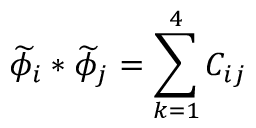<formula> <loc_0><loc_0><loc_500><loc_500>\widetilde { \phi } _ { i } \ast \widetilde { \phi } _ { j } = \sum _ { k = 1 } ^ { 4 } C _ { i j }</formula> 